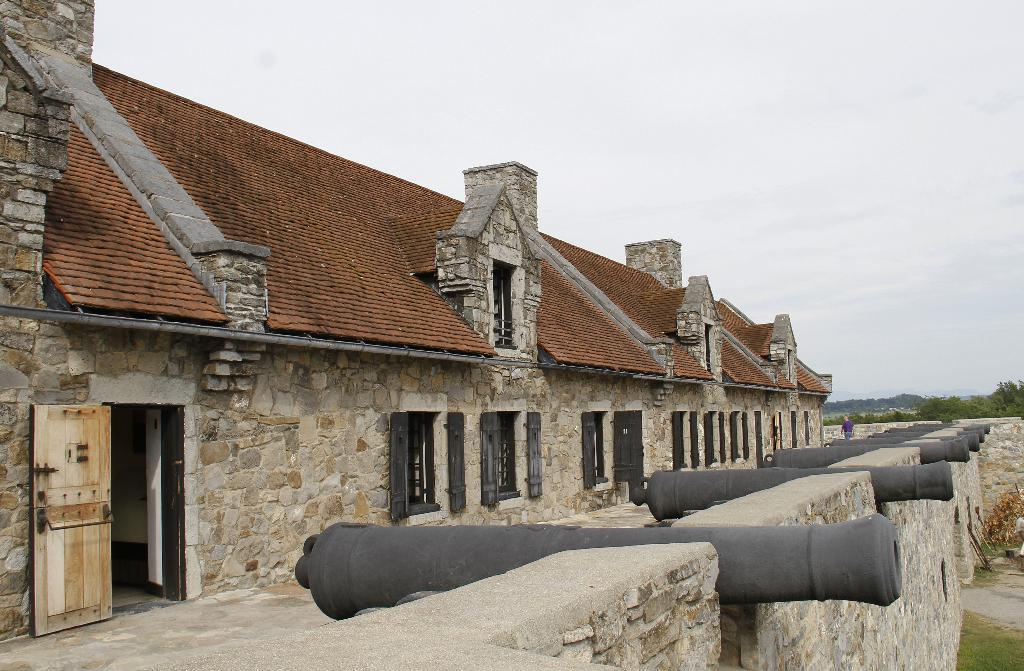What type of structures can be seen in the image? There are buildings in the image. What other natural elements are present in the image? There are trees and grass on the ground in the image. How would you describe the sky in the image? The sky is cloudy in the image. Can you identify any specific architectural features in the image? There is a wooden door in the image. What type of garden can be seen in the image? There is no garden present in the image. Can you tell me how many people are crying in the image? There are no people or crying depicted in the image. 